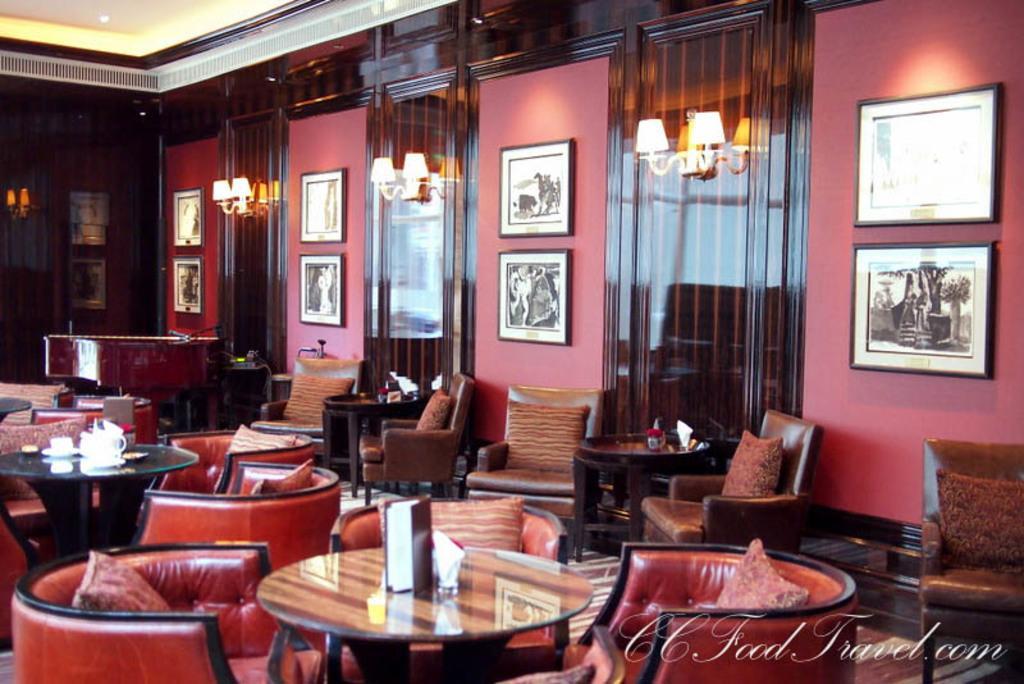In one or two sentences, can you explain what this image depicts? There is a room and there is a sofa set and chairs. There is a cup and menu book on a table. We can see in the background there is lighting,curtains and photo frames. 